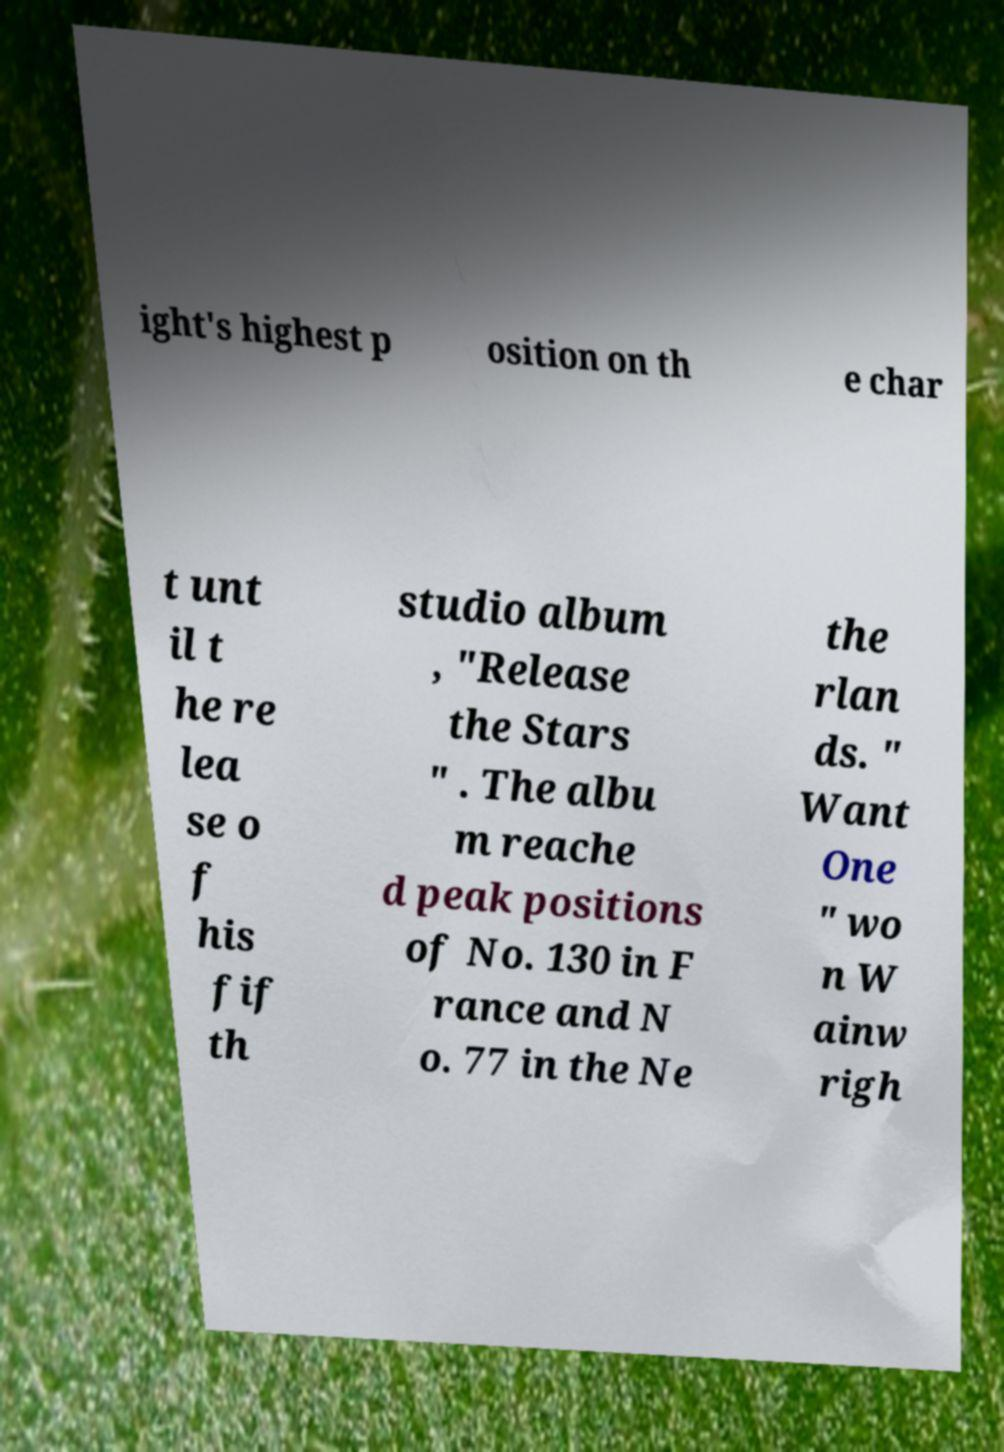Please identify and transcribe the text found in this image. ight's highest p osition on th e char t unt il t he re lea se o f his fif th studio album , "Release the Stars " . The albu m reache d peak positions of No. 130 in F rance and N o. 77 in the Ne the rlan ds. " Want One " wo n W ainw righ 